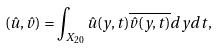Convert formula to latex. <formula><loc_0><loc_0><loc_500><loc_500>( \hat { u } , \hat { v } ) = \int _ { X _ { 2 0 } } \hat { u } ( y , t ) \overline { \hat { v } ( y , t ) } d y d t ,</formula> 